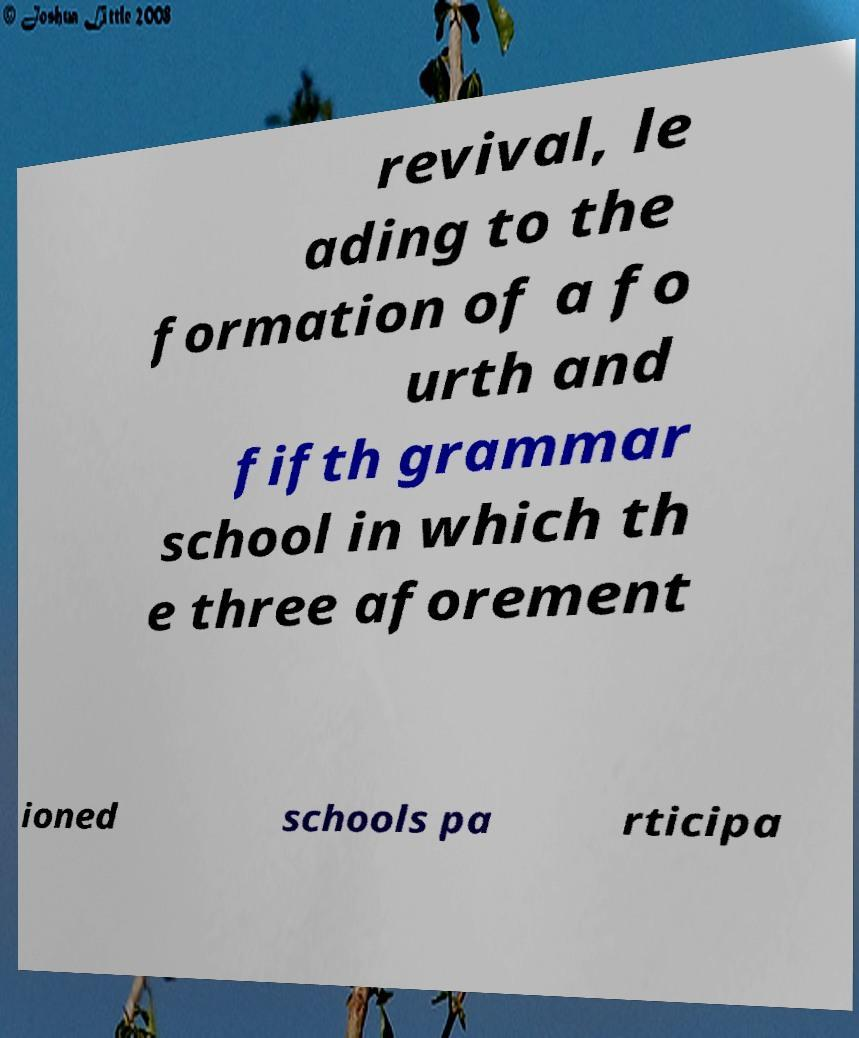Please read and relay the text visible in this image. What does it say? revival, le ading to the formation of a fo urth and fifth grammar school in which th e three aforement ioned schools pa rticipa 